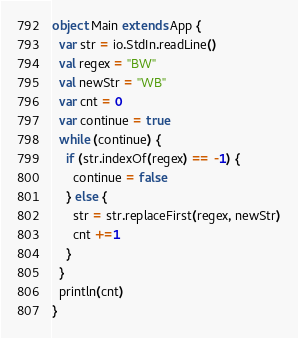Convert code to text. <code><loc_0><loc_0><loc_500><loc_500><_Scala_>object Main extends App {
  var str = io.StdIn.readLine()
  val regex = "BW"
  val newStr = "WB"
  var cnt = 0
  var continue = true
  while (continue) {
    if (str.indexOf(regex) == -1) {
      continue = false
    } else {
      str = str.replaceFirst(regex, newStr)
      cnt +=1
    }
  }
  println(cnt)
}
</code> 